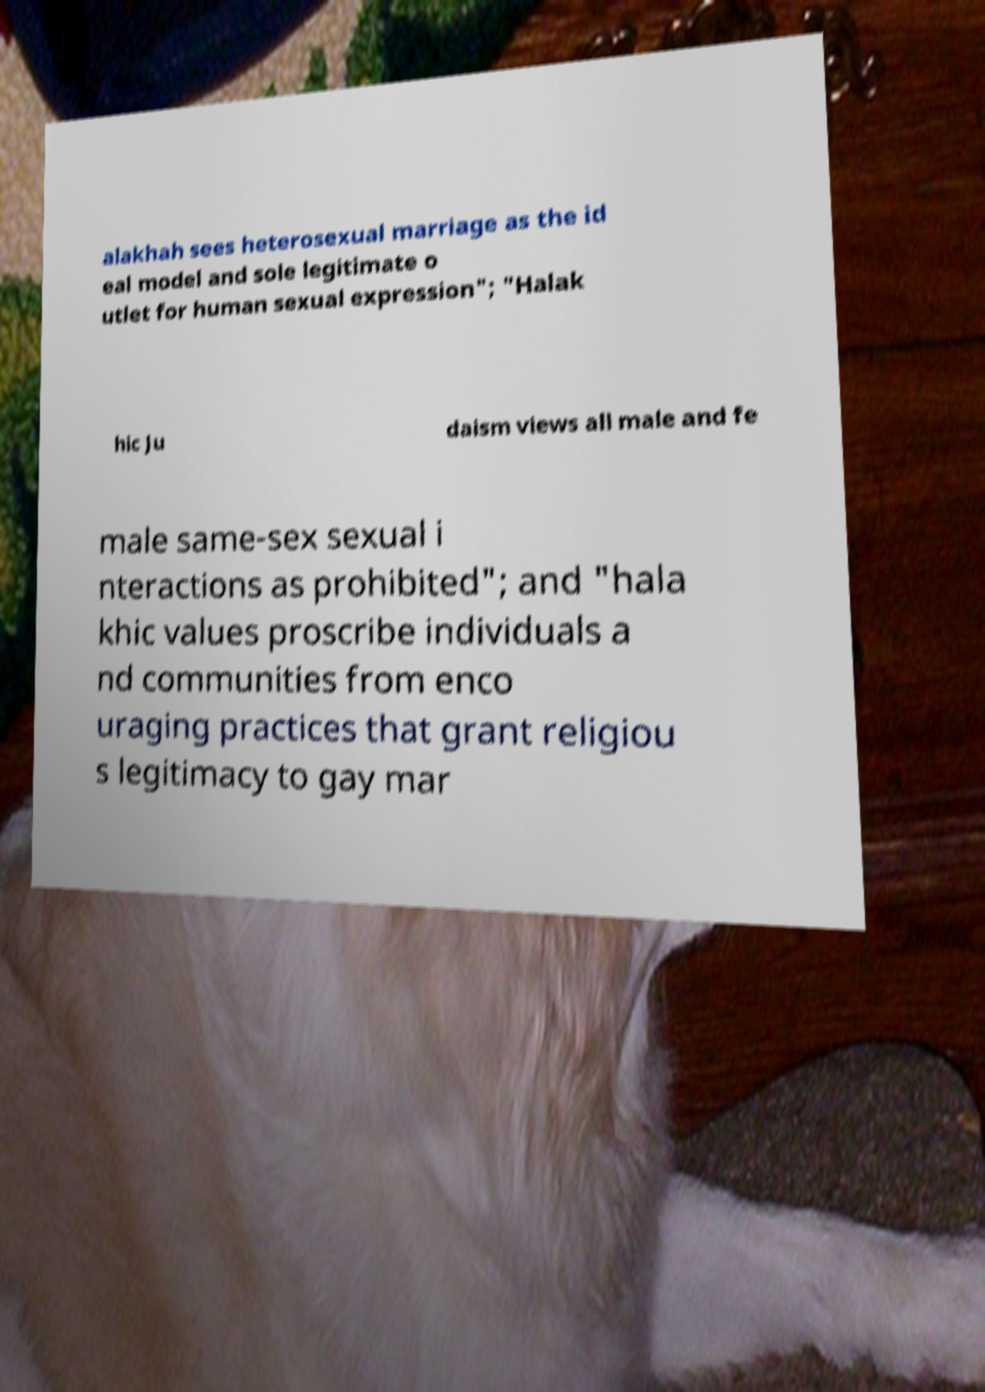Please identify and transcribe the text found in this image. alakhah sees heterosexual marriage as the id eal model and sole legitimate o utlet for human sexual expression"; "Halak hic Ju daism views all male and fe male same-sex sexual i nteractions as prohibited"; and "hala khic values proscribe individuals a nd communities from enco uraging practices that grant religiou s legitimacy to gay mar 